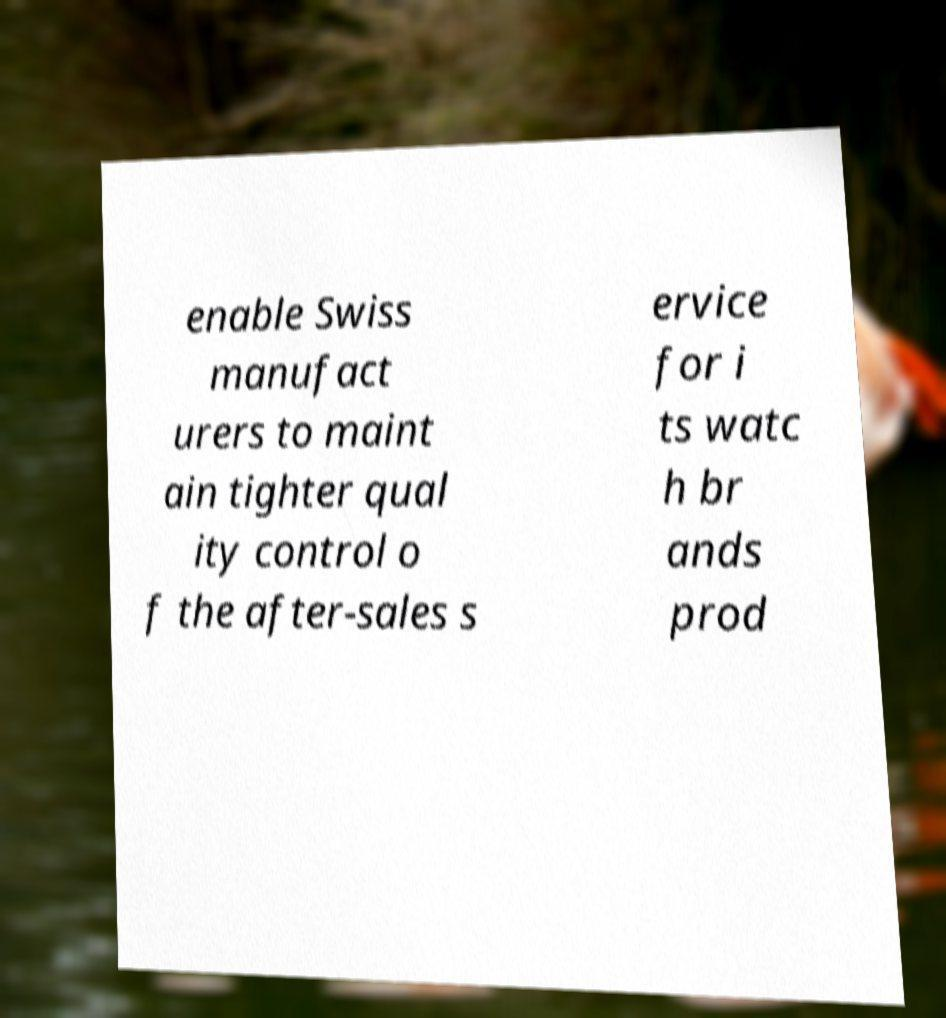I need the written content from this picture converted into text. Can you do that? enable Swiss manufact urers to maint ain tighter qual ity control o f the after-sales s ervice for i ts watc h br ands prod 